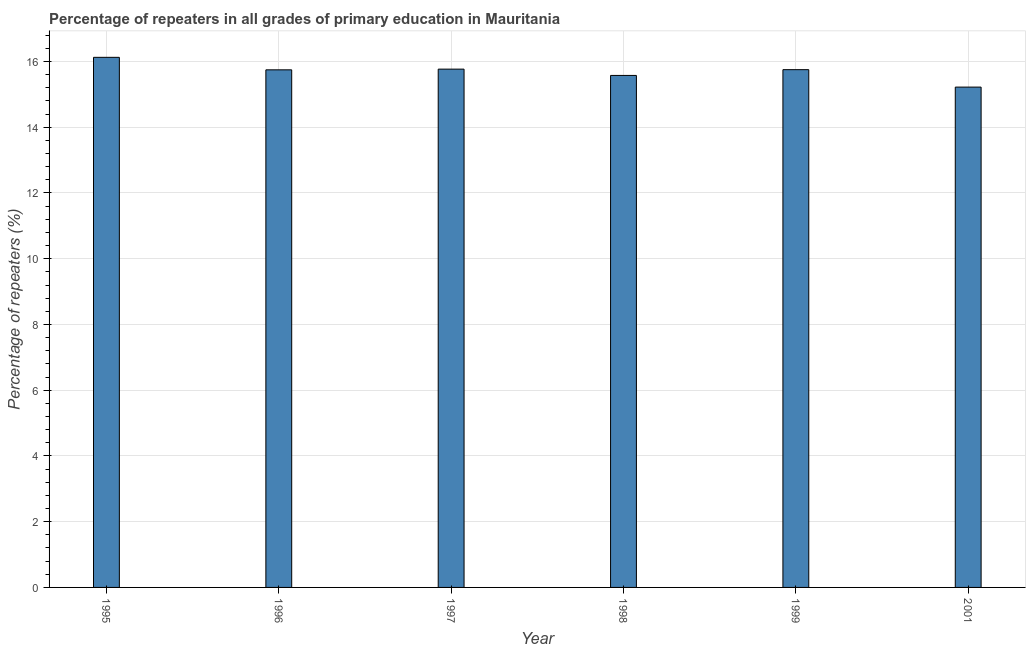Does the graph contain any zero values?
Give a very brief answer. No. What is the title of the graph?
Keep it short and to the point. Percentage of repeaters in all grades of primary education in Mauritania. What is the label or title of the X-axis?
Give a very brief answer. Year. What is the label or title of the Y-axis?
Provide a succinct answer. Percentage of repeaters (%). What is the percentage of repeaters in primary education in 2001?
Provide a succinct answer. 15.22. Across all years, what is the maximum percentage of repeaters in primary education?
Make the answer very short. 16.13. Across all years, what is the minimum percentage of repeaters in primary education?
Ensure brevity in your answer.  15.22. What is the sum of the percentage of repeaters in primary education?
Your answer should be compact. 94.19. What is the difference between the percentage of repeaters in primary education in 1997 and 1998?
Ensure brevity in your answer.  0.19. What is the average percentage of repeaters in primary education per year?
Your answer should be very brief. 15.7. What is the median percentage of repeaters in primary education?
Provide a short and direct response. 15.75. What is the ratio of the percentage of repeaters in primary education in 1999 to that in 2001?
Your answer should be compact. 1.03. Is the difference between the percentage of repeaters in primary education in 1996 and 2001 greater than the difference between any two years?
Provide a succinct answer. No. What is the difference between the highest and the second highest percentage of repeaters in primary education?
Offer a terse response. 0.36. Is the sum of the percentage of repeaters in primary education in 1996 and 2001 greater than the maximum percentage of repeaters in primary education across all years?
Provide a short and direct response. Yes. What is the difference between the highest and the lowest percentage of repeaters in primary education?
Give a very brief answer. 0.91. Are the values on the major ticks of Y-axis written in scientific E-notation?
Your answer should be very brief. No. What is the Percentage of repeaters (%) of 1995?
Give a very brief answer. 16.13. What is the Percentage of repeaters (%) in 1996?
Keep it short and to the point. 15.75. What is the Percentage of repeaters (%) of 1997?
Offer a terse response. 15.77. What is the Percentage of repeaters (%) in 1998?
Your answer should be very brief. 15.58. What is the Percentage of repeaters (%) of 1999?
Keep it short and to the point. 15.75. What is the Percentage of repeaters (%) in 2001?
Your response must be concise. 15.22. What is the difference between the Percentage of repeaters (%) in 1995 and 1996?
Your answer should be very brief. 0.38. What is the difference between the Percentage of repeaters (%) in 1995 and 1997?
Ensure brevity in your answer.  0.36. What is the difference between the Percentage of repeaters (%) in 1995 and 1998?
Your answer should be very brief. 0.55. What is the difference between the Percentage of repeaters (%) in 1995 and 1999?
Make the answer very short. 0.38. What is the difference between the Percentage of repeaters (%) in 1995 and 2001?
Your answer should be compact. 0.91. What is the difference between the Percentage of repeaters (%) in 1996 and 1997?
Your response must be concise. -0.02. What is the difference between the Percentage of repeaters (%) in 1996 and 1998?
Your answer should be compact. 0.17. What is the difference between the Percentage of repeaters (%) in 1996 and 1999?
Keep it short and to the point. -0.01. What is the difference between the Percentage of repeaters (%) in 1996 and 2001?
Offer a very short reply. 0.53. What is the difference between the Percentage of repeaters (%) in 1997 and 1998?
Keep it short and to the point. 0.19. What is the difference between the Percentage of repeaters (%) in 1997 and 1999?
Your answer should be very brief. 0.02. What is the difference between the Percentage of repeaters (%) in 1997 and 2001?
Offer a terse response. 0.55. What is the difference between the Percentage of repeaters (%) in 1998 and 1999?
Your response must be concise. -0.18. What is the difference between the Percentage of repeaters (%) in 1998 and 2001?
Your answer should be very brief. 0.36. What is the difference between the Percentage of repeaters (%) in 1999 and 2001?
Offer a terse response. 0.53. What is the ratio of the Percentage of repeaters (%) in 1995 to that in 1998?
Give a very brief answer. 1.03. What is the ratio of the Percentage of repeaters (%) in 1995 to that in 1999?
Your response must be concise. 1.02. What is the ratio of the Percentage of repeaters (%) in 1995 to that in 2001?
Ensure brevity in your answer.  1.06. What is the ratio of the Percentage of repeaters (%) in 1996 to that in 2001?
Offer a very short reply. 1.03. What is the ratio of the Percentage of repeaters (%) in 1997 to that in 2001?
Keep it short and to the point. 1.04. What is the ratio of the Percentage of repeaters (%) in 1998 to that in 1999?
Make the answer very short. 0.99. What is the ratio of the Percentage of repeaters (%) in 1999 to that in 2001?
Ensure brevity in your answer.  1.03. 